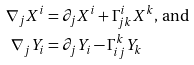<formula> <loc_0><loc_0><loc_500><loc_500>\nabla _ { j } X ^ { i } & = \partial _ { j } X ^ { i } + \Gamma ^ { i } _ { j k } X ^ { k } \text {, and} \\ \nabla _ { j } Y _ { i } & = \partial _ { j } Y _ { i } - \Gamma ^ { k } _ { i j } Y _ { k }</formula> 